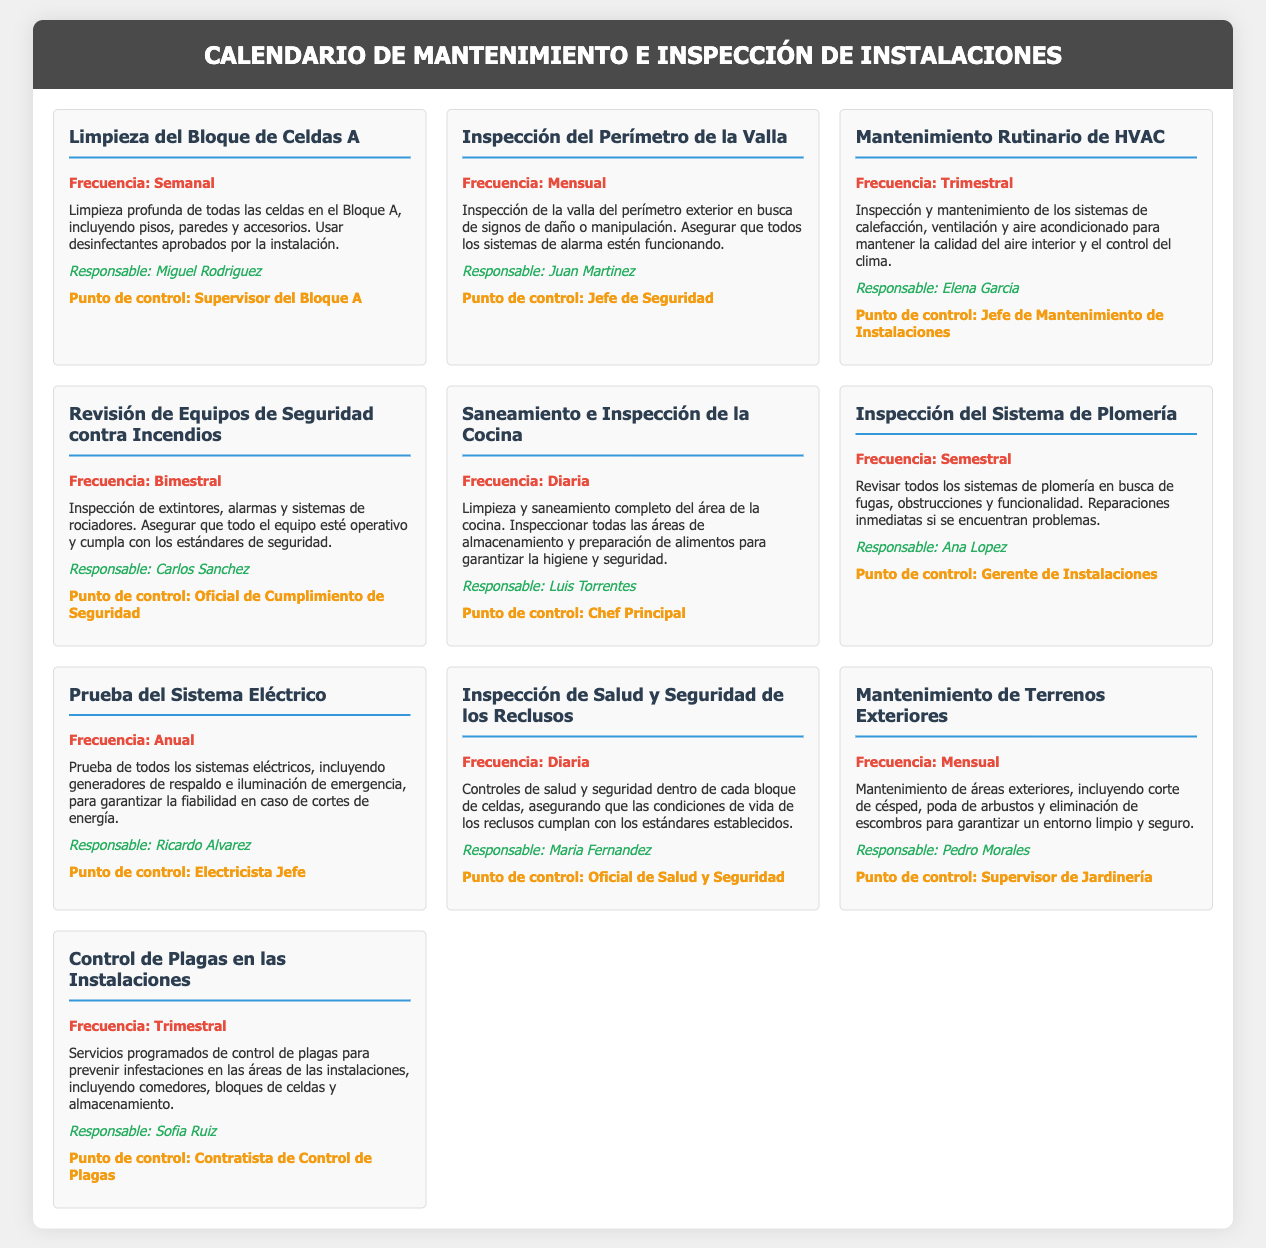¿Cuál es la frecuencia de la limpieza del bloque de celdas A? La frecuencia de limpieza del bloque de celdas A es semanal, según el calendario.
Answer: Semanal ¿Quién es responsable de la inspección del perímetro de la valla? El documento indica que Juan Martinez es el responsable de la inspección del perímetro de la valla.
Answer: Juan Martinez ¿Qué tipo de mantenimiento se realiza trimestralmente? En el calendario se menciona el mantenimiento rutinario de HVAC, que se realiza trimestralmente.
Answer: Mantenimiento Rutinario de HVAC ¿Cuántas veces se inspecciona el sistema de plomería al año? El sistema de plomería se inspecciona semestralmente, lo que implica que se realiza dos veces al año.
Answer: Dos veces ¿Cuál es el punto de control para la revisión de equipos de seguridad contra incendios? El punto de control para la revisión de equipos de seguridad contra incendios es el Oficial de Cumplimiento de Seguridad.
Answer: Oficial de Cumplimiento de Seguridad ¿Cuál es la frecuencia de la limpieza y saneamiento de la cocina? La limpieza y saneamiento de la cocina se realiza diariamente, según el calendario.
Answer: Diaria ¿Quién es responsable del mantenimiento de terrenos exteriores? Pedro Morales es el responsable del mantenimiento de terrenos exteriores según el documento.
Answer: Pedro Morales ¿Cuál es la frecuencia de las inspecciones de salud y seguridad de los reclusos? Las inspecciones de salud y seguridad de los reclusos son diarias, como se indica en el calendario.
Answer: Diaria ¿Qué actividad se realiza mensualmente relacionada con el mantenimiento? El mantenimiento de terrenos exteriores se realiza mensualmente según el calendario proporcionado.
Answer: Mantenimiento de Terrenos Exteriores 